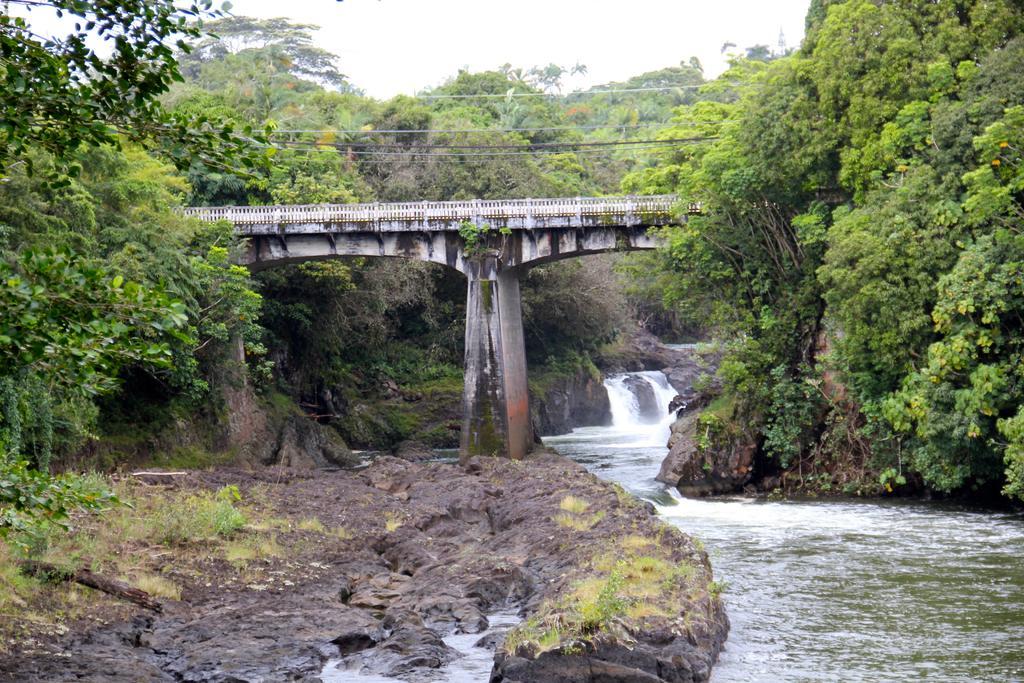How would you summarize this image in a sentence or two? In the center of the image we can see bridge, wires, water, mountains, trees. At the top of the image there is a sky. At the bottom of the image we can see rocks, water. 